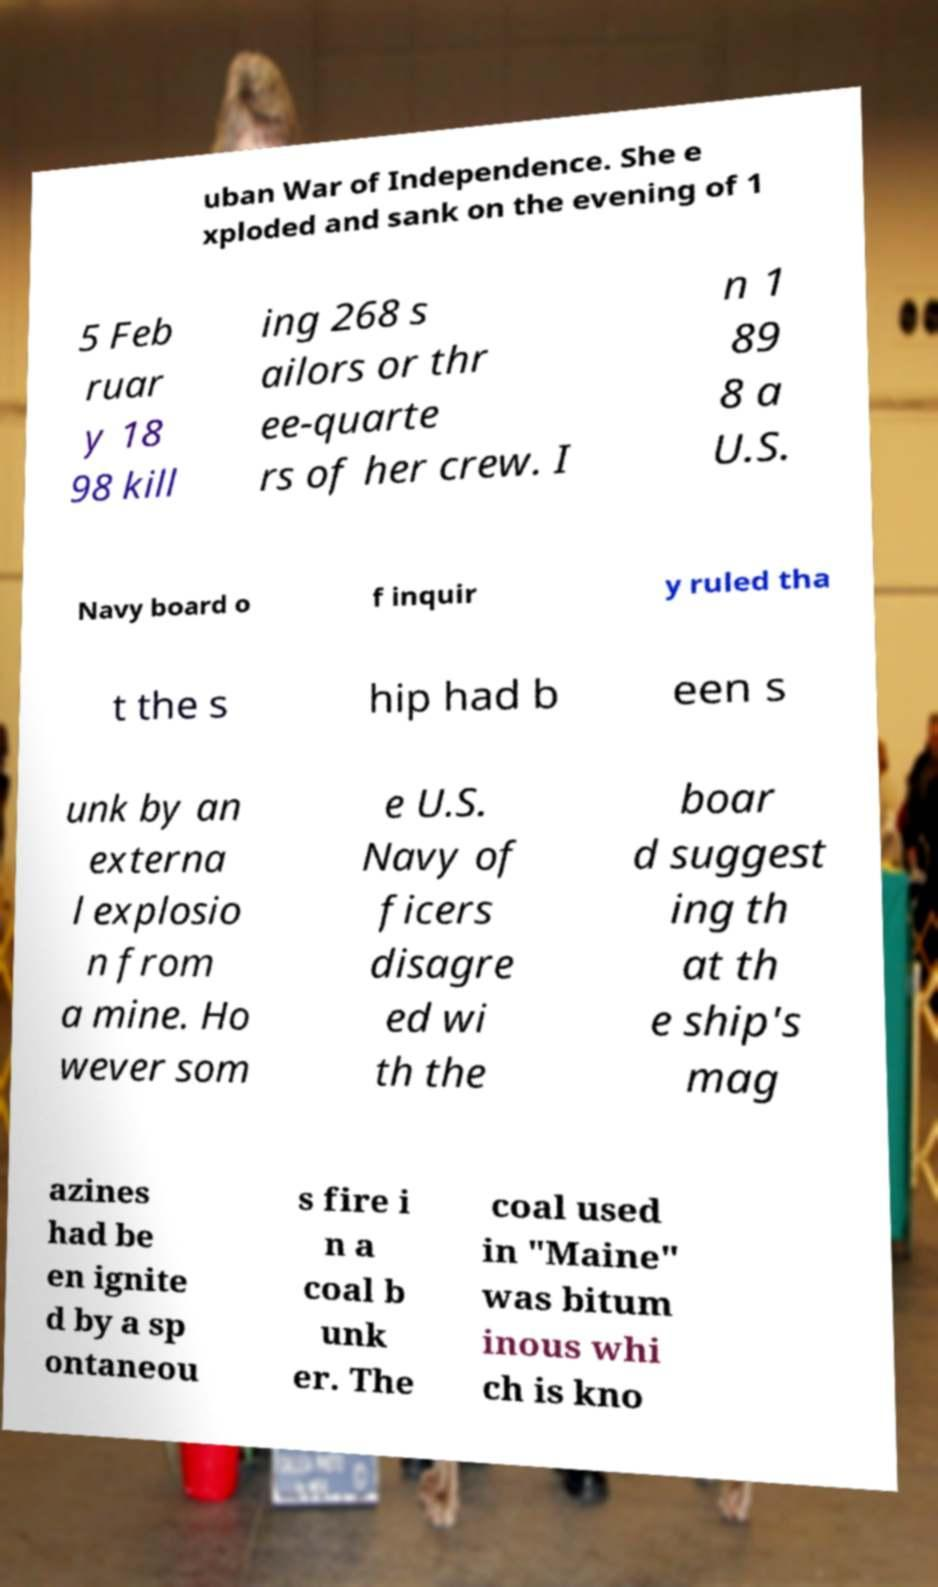Please read and relay the text visible in this image. What does it say? uban War of Independence. She e xploded and sank on the evening of 1 5 Feb ruar y 18 98 kill ing 268 s ailors or thr ee-quarte rs of her crew. I n 1 89 8 a U.S. Navy board o f inquir y ruled tha t the s hip had b een s unk by an externa l explosio n from a mine. Ho wever som e U.S. Navy of ficers disagre ed wi th the boar d suggest ing th at th e ship's mag azines had be en ignite d by a sp ontaneou s fire i n a coal b unk er. The coal used in "Maine" was bitum inous whi ch is kno 